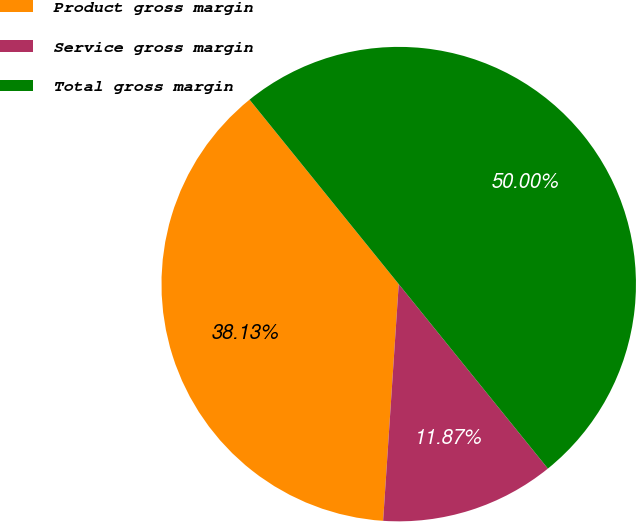Convert chart to OTSL. <chart><loc_0><loc_0><loc_500><loc_500><pie_chart><fcel>Product gross margin<fcel>Service gross margin<fcel>Total gross margin<nl><fcel>38.13%<fcel>11.87%<fcel>50.0%<nl></chart> 